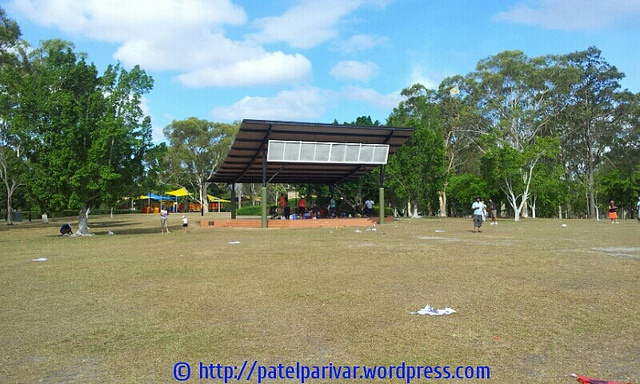Describe the objects in this image and their specific colors. I can see people in lightblue, black, gray, and darkgreen tones, people in lightblue, gray, and darkgray tones, kite in lightblue, white, darkgray, and gray tones, people in lightblue, gray, darkgray, and lightgray tones, and people in lightblue, black, tan, salmon, and gray tones in this image. 